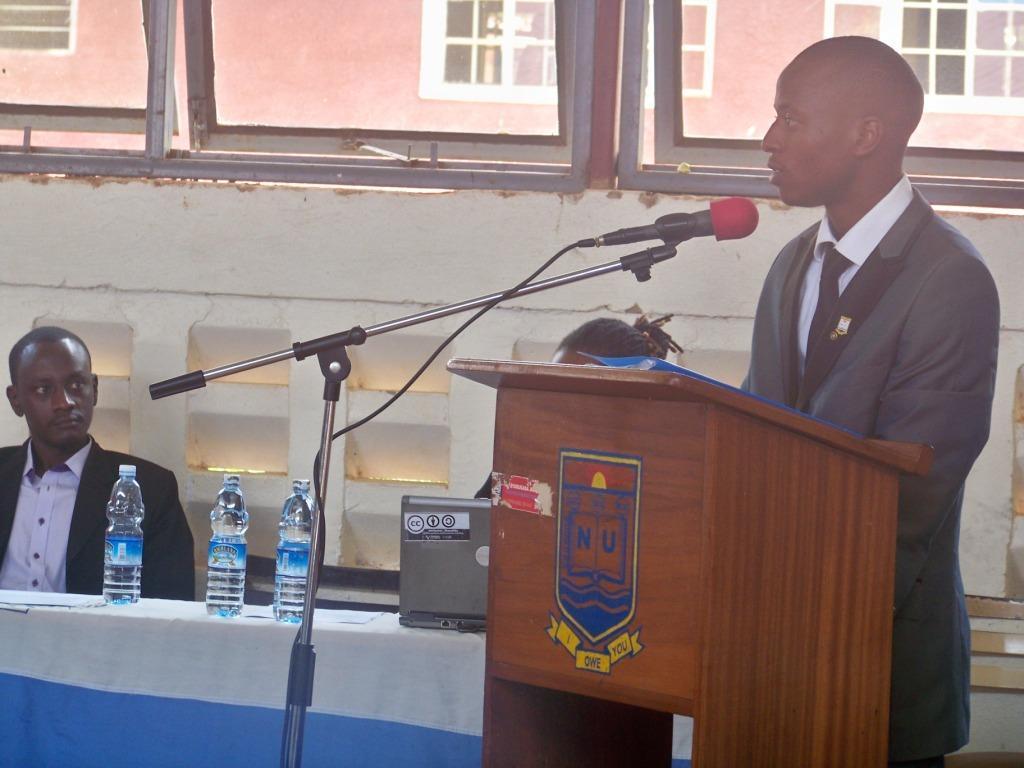Could you give a brief overview of what you see in this image? In the picture we can see two men, one man is sitting and one man is standing near the table and talking in microphone. Person who is sitting is wearing a black blazer near the table, on the table we can find some bottles, laptop. In the background we can find a wall, windows, from the windows we can find a building. 